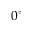Convert formula to latex. <formula><loc_0><loc_0><loc_500><loc_500>0 ^ { \circ }</formula> 